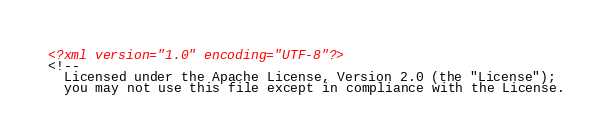<code> <loc_0><loc_0><loc_500><loc_500><_XML_><?xml version="1.0" encoding="UTF-8"?>
<!--
  Licensed under the Apache License, Version 2.0 (the "License");
  you may not use this file except in compliance with the License.</code> 